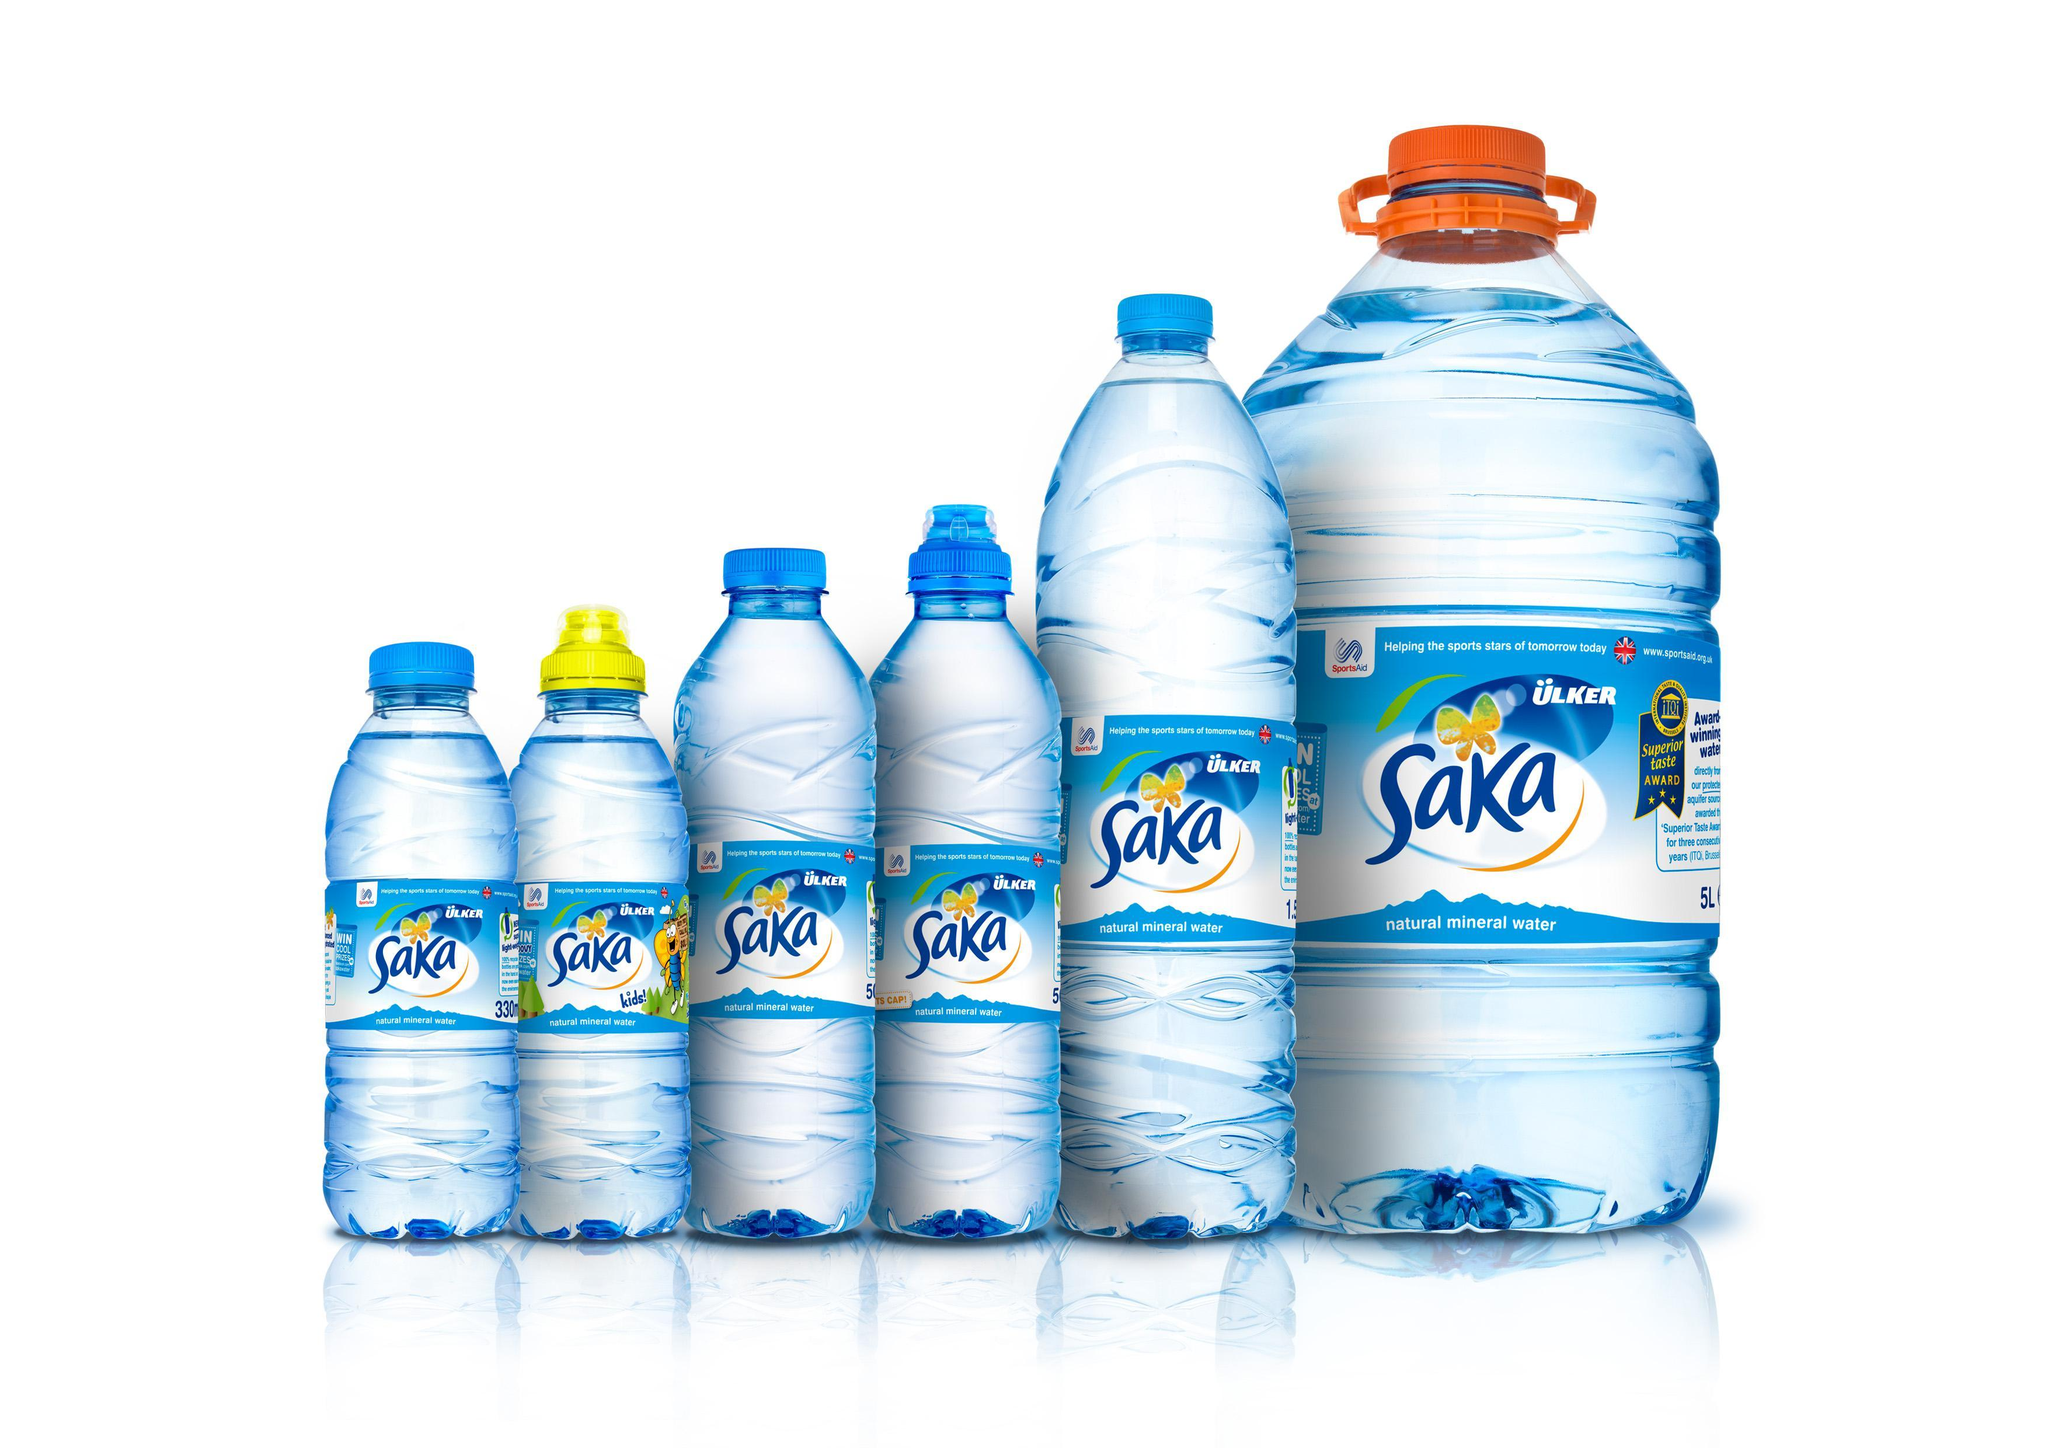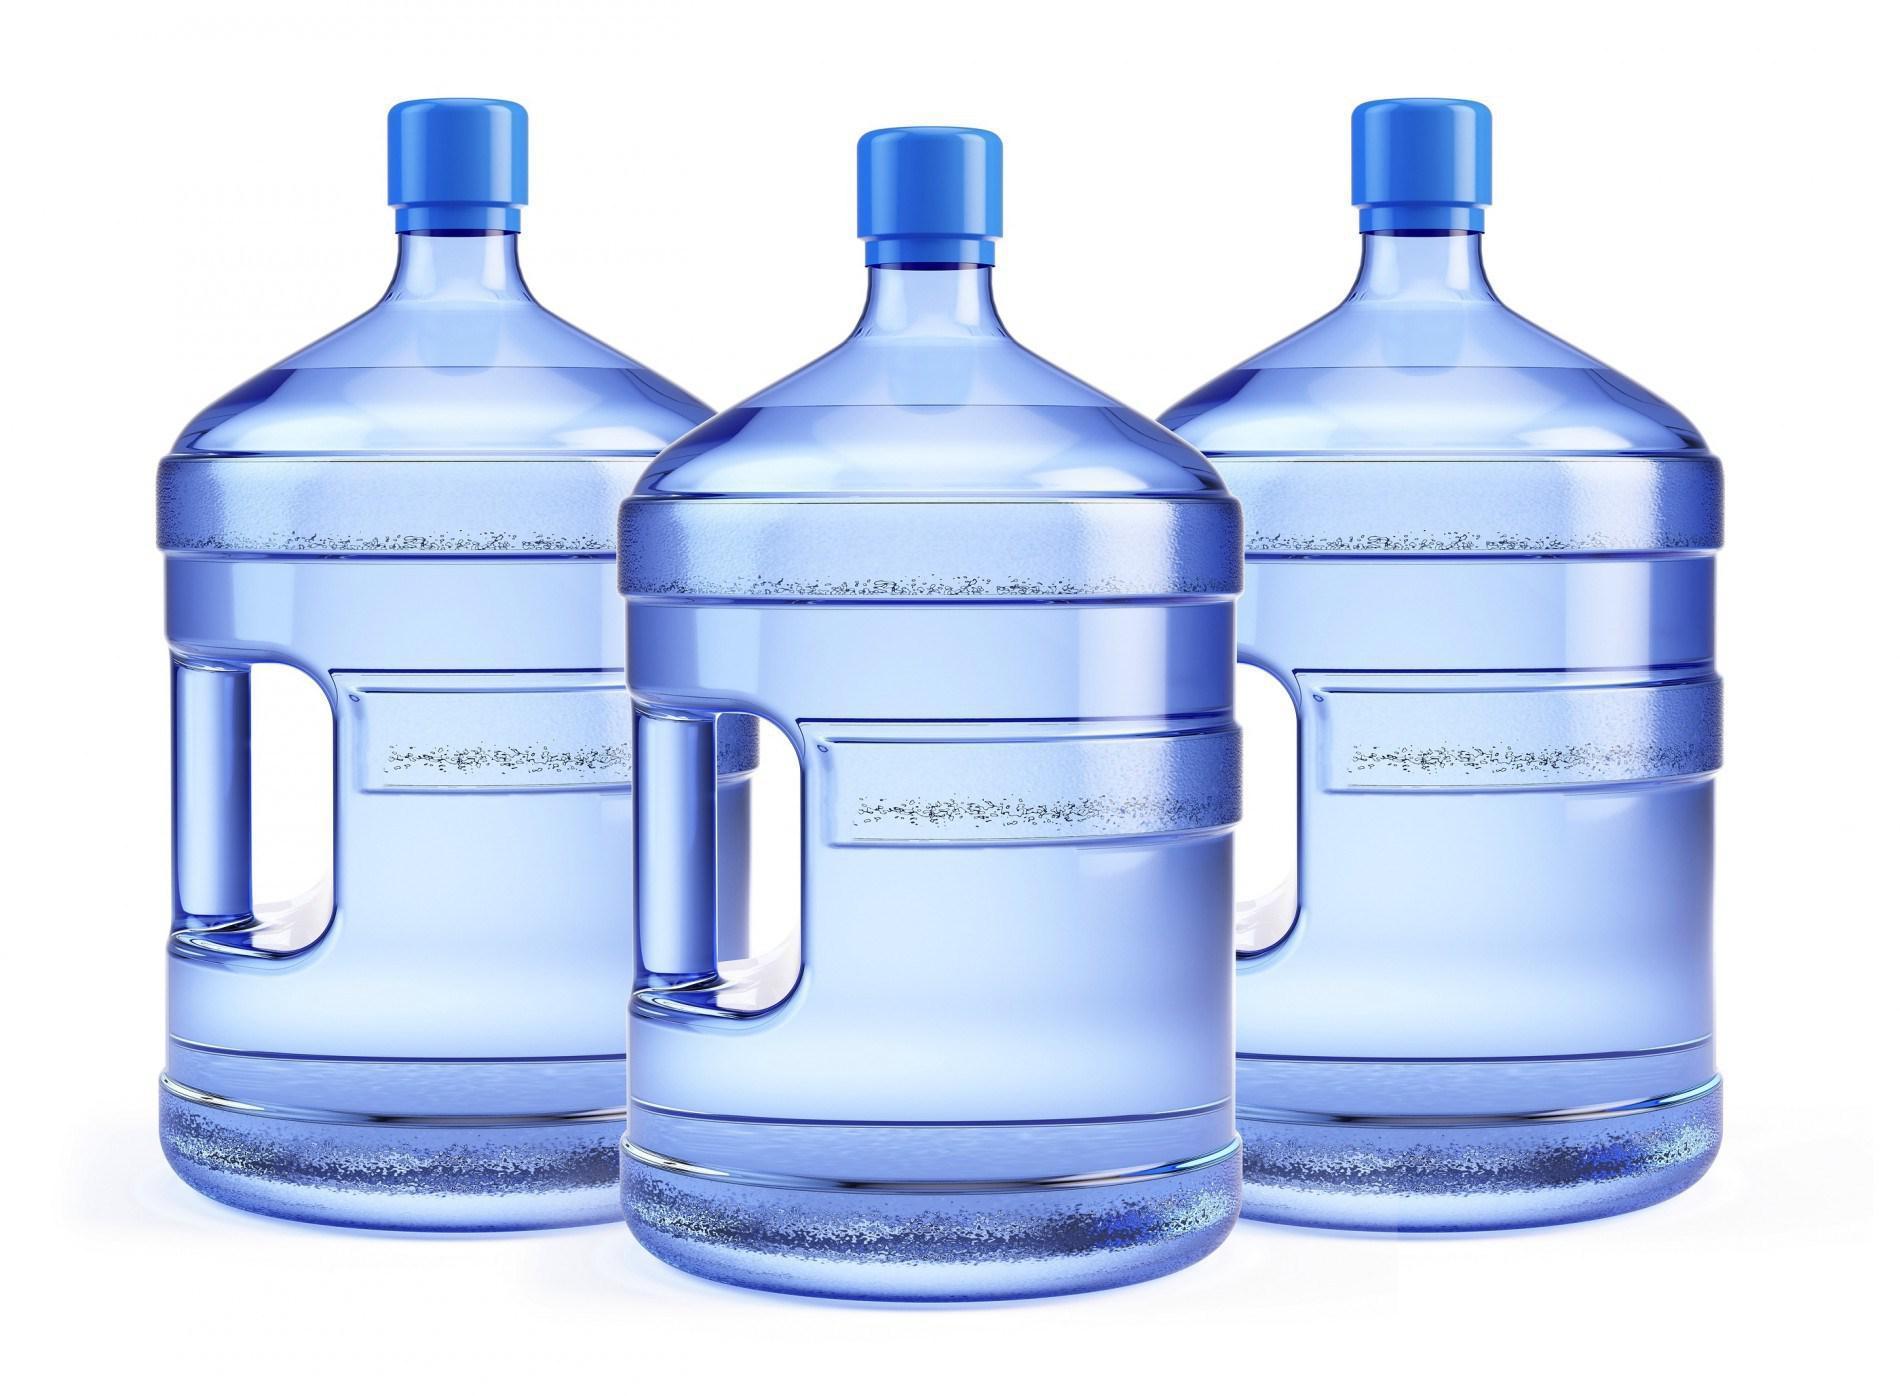The first image is the image on the left, the second image is the image on the right. Given the left and right images, does the statement "All bottles are upright and have lids on them, and at least some bottles have visible labels." hold true? Answer yes or no. Yes. 